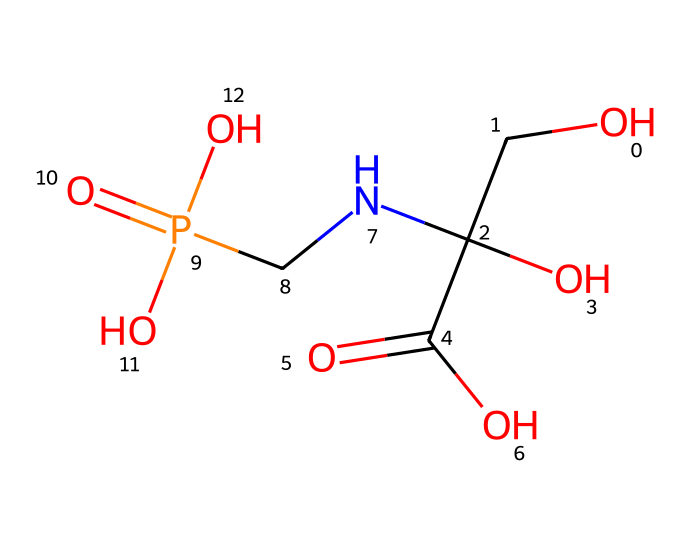What is the molecular formula of glyphosate? To determine the molecular formula from the SMILES notation, count the number of each type of atom in the structure. The SMILES corresponds to one carbon(w), three oxygen(o), one nitrogen(n), one phosphorus(p), and five hydrogen(H) atoms. Therefore, adding them together gives C3H8N5O5P.
Answer: C3H8N5O5P How many carbon atoms are in glyphosate? By analyzing the SMILES representation, there are three occurrences of carbon (C) represented in the formula. Thus, glyphosate contains three carbon atoms.
Answer: 3 What functional groups are present in glyphosate? Looking through the SMILES, we can identify carboxyl (-COOH), amino (-NH), and phosphonic acids (due to phosphorus interactions) as functional groups present in glyphosate. Each function is defined by specific groups in the chemical structure.
Answer: carboxyl, amino, phosphonic What is the central atom in glyphosate that connects to oxygen and nitrogen? The structure reveals that the central atom connecting different parts of glyphosate is a phosphorus atom (P), making it crucial for its chemical behavior.
Answer: phosphorus How does the presence of the carboxyl group affect glyphosate's function as a herbicide? The carboxyl group (-COOH) in glyphosate is hydrophilic, allowing it to solubilize in water. This enhances glyphosate's ability to be absorbed by plants, which is essential for its action as an herbicide.
Answer: enhances absorption What is the significance of the nitrogen atom in glyphosate? The nitrogen atom (N) serves as a basic site within the structure, contributing to the herbicide's mechanism by facilitating binding with target enzymes in the plants, enabling its herbicidal activity.
Answer: enzyme binding What is the characteristic feature of glyphosate that makes it a systemic herbicide? Glyphosate's ability to be absorbed and translocated through the plant system due to its chemical structure, which includes functional groups that facilitate movement, makes it a systemic herbicide.
Answer: systemic translocation 